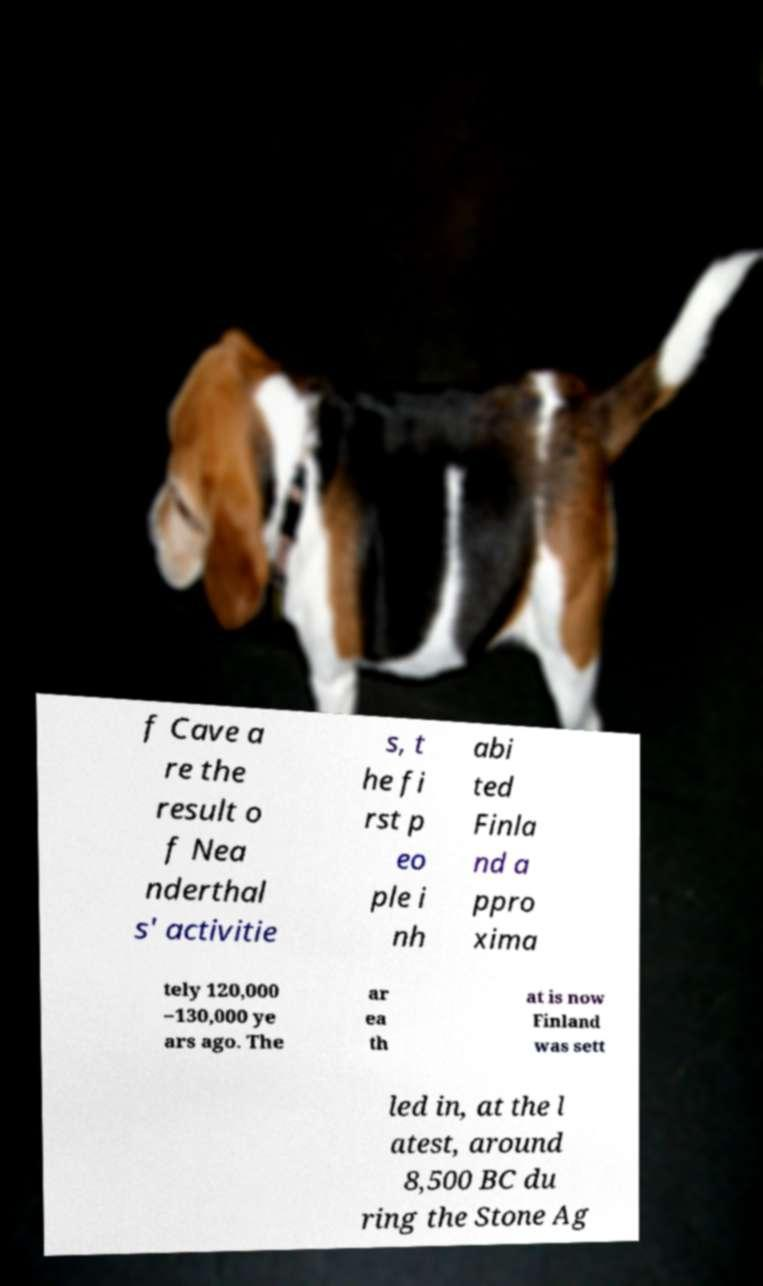Please identify and transcribe the text found in this image. f Cave a re the result o f Nea nderthal s' activitie s, t he fi rst p eo ple i nh abi ted Finla nd a ppro xima tely 120,000 –130,000 ye ars ago. The ar ea th at is now Finland was sett led in, at the l atest, around 8,500 BC du ring the Stone Ag 